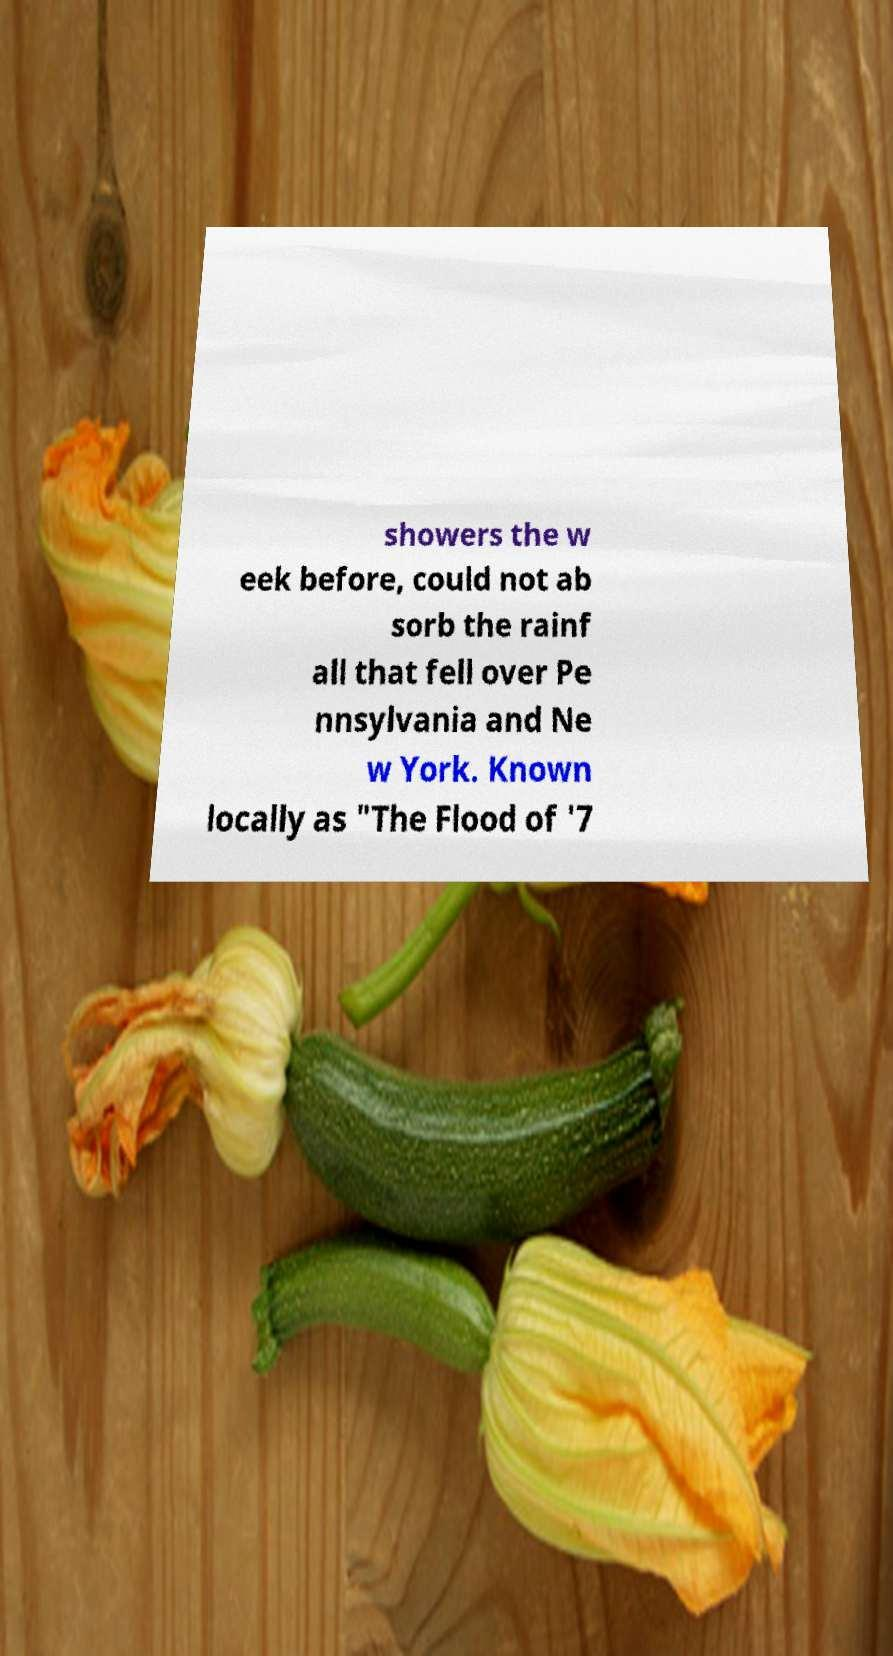For documentation purposes, I need the text within this image transcribed. Could you provide that? showers the w eek before, could not ab sorb the rainf all that fell over Pe nnsylvania and Ne w York. Known locally as "The Flood of '7 